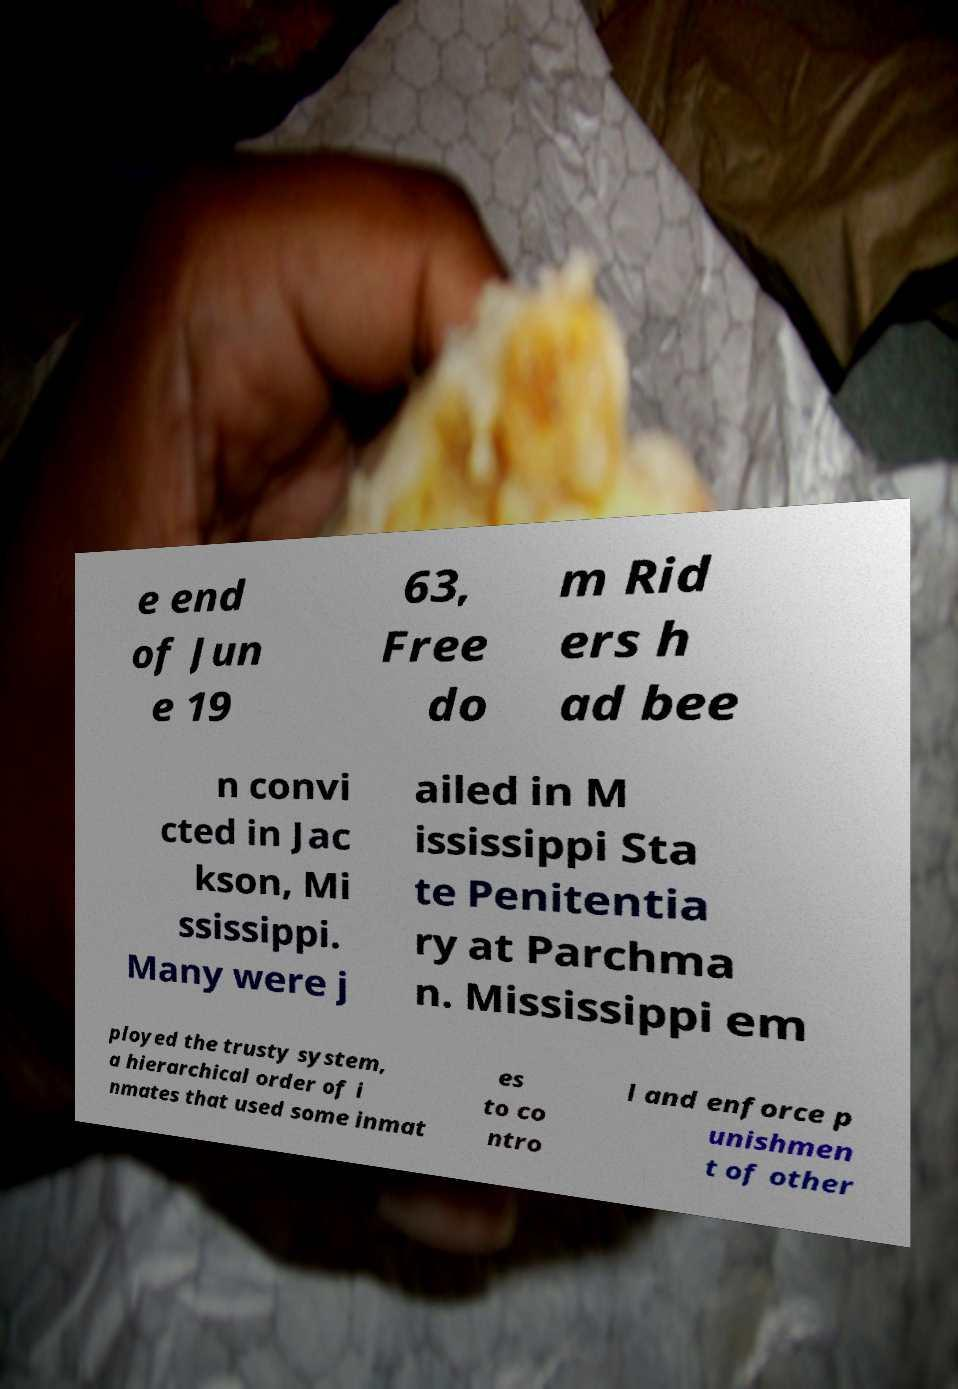Could you assist in decoding the text presented in this image and type it out clearly? e end of Jun e 19 63, Free do m Rid ers h ad bee n convi cted in Jac kson, Mi ssissippi. Many were j ailed in M ississippi Sta te Penitentia ry at Parchma n. Mississippi em ployed the trusty system, a hierarchical order of i nmates that used some inmat es to co ntro l and enforce p unishmen t of other 